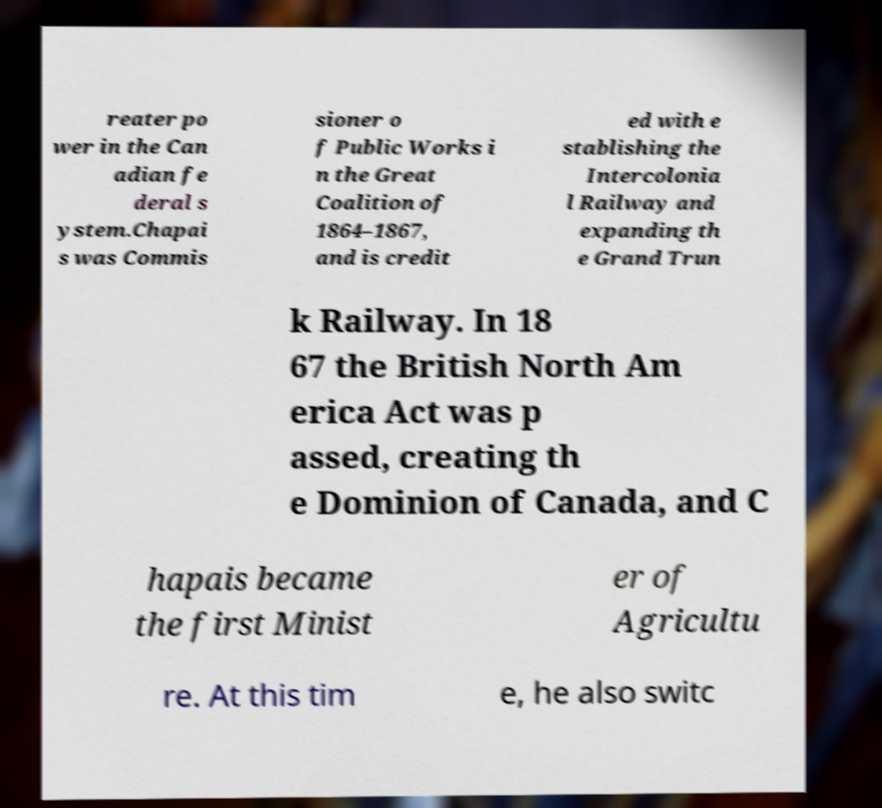For documentation purposes, I need the text within this image transcribed. Could you provide that? reater po wer in the Can adian fe deral s ystem.Chapai s was Commis sioner o f Public Works i n the Great Coalition of 1864–1867, and is credit ed with e stablishing the Intercolonia l Railway and expanding th e Grand Trun k Railway. In 18 67 the British North Am erica Act was p assed, creating th e Dominion of Canada, and C hapais became the first Minist er of Agricultu re. At this tim e, he also switc 